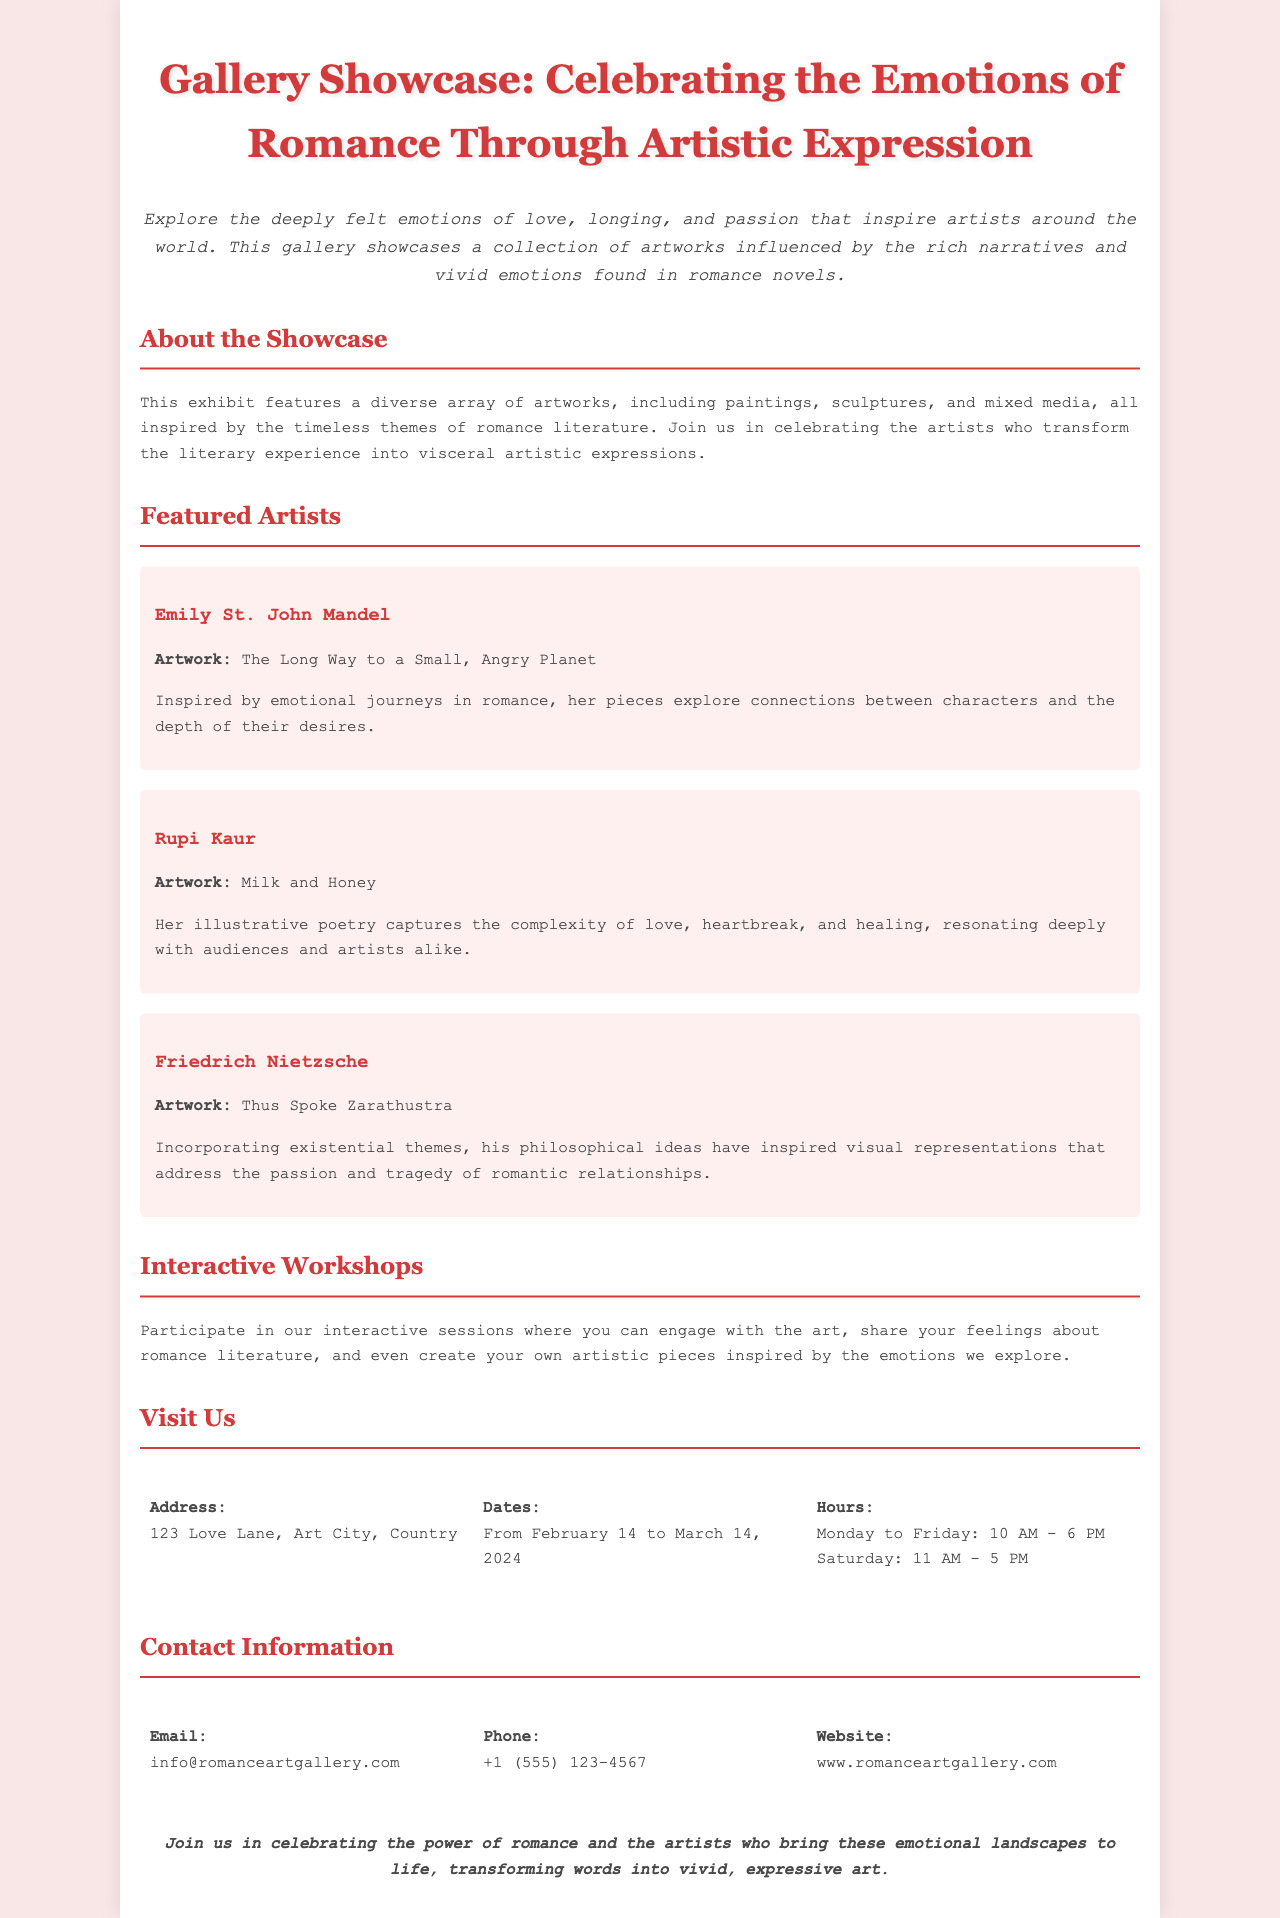what is the title of the showcase? The title is explicitly mentioned at the top of the document.
Answer: Gallery Showcase: Celebrating the Emotions of Romance Through Artistic Expression when does the exhibit start? The starting date of the exhibit is clearly stated in the visiting information section.
Answer: February 14 who is one of the featured artists? The document lists several featured artists, and their names are provided in the section about featured artists.
Answer: Emily St. John Mandel how long does the exhibit run? The duration of the exhibit is indicated in the visiting information section.
Answer: One month what type of art is featured in the showcase? The document provides information about the types of artworks included in the exhibit.
Answer: Paintings, sculptures, and mixed media what can participants create in the workshops? The document mentions what activities are included in the interactive workshops section.
Answer: Artistic pieces what is the closing statement about? The closing statement summarizes the purpose of the gallery showcase.
Answer: Celebrating the power of romance what is the address of the showcase? The address information is explicitly provided in the visiting information section.
Answer: 123 Love Lane, Art City, Country 